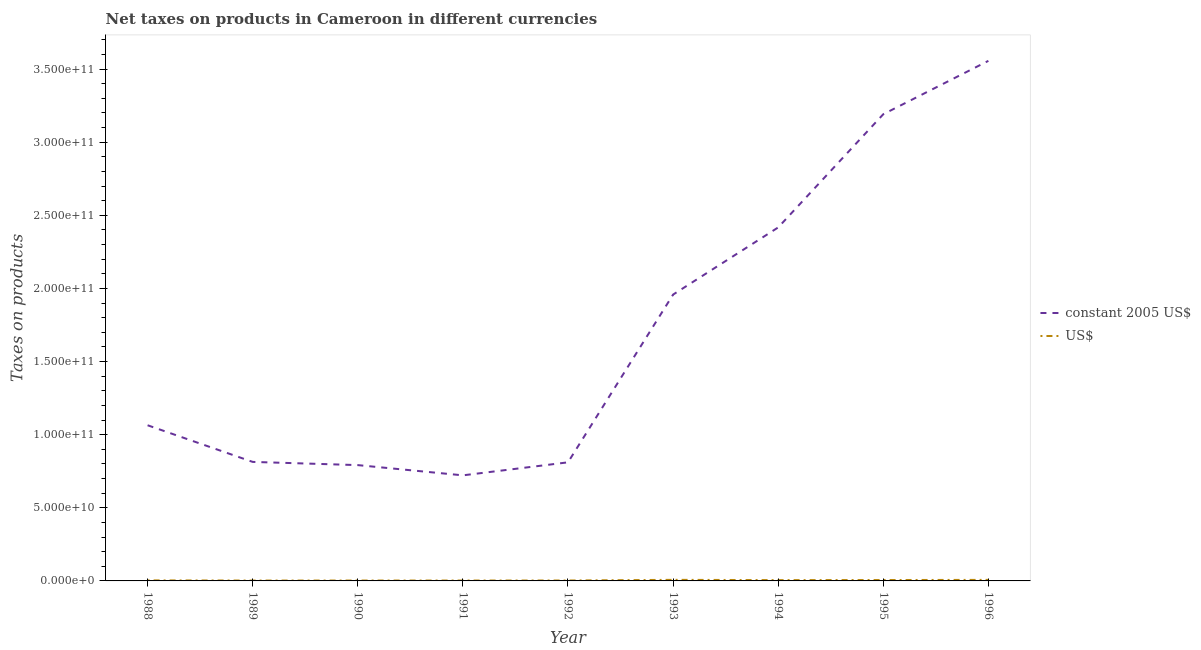Does the line corresponding to net taxes in constant 2005 us$ intersect with the line corresponding to net taxes in us$?
Your answer should be very brief. No. Is the number of lines equal to the number of legend labels?
Ensure brevity in your answer.  Yes. What is the net taxes in constant 2005 us$ in 1991?
Provide a succinct answer. 7.22e+1. Across all years, what is the maximum net taxes in us$?
Ensure brevity in your answer.  7.38e+08. Across all years, what is the minimum net taxes in us$?
Keep it short and to the point. 2.58e+08. In which year was the net taxes in constant 2005 us$ maximum?
Your response must be concise. 1996. What is the total net taxes in constant 2005 us$ in the graph?
Your response must be concise. 1.53e+12. What is the difference between the net taxes in constant 2005 us$ in 1995 and that in 1996?
Your answer should be compact. -3.65e+1. What is the difference between the net taxes in us$ in 1988 and the net taxes in constant 2005 us$ in 1990?
Offer a very short reply. -7.88e+1. What is the average net taxes in constant 2005 us$ per year?
Ensure brevity in your answer.  1.70e+11. In the year 1988, what is the difference between the net taxes in us$ and net taxes in constant 2005 us$?
Provide a short and direct response. -1.06e+11. What is the ratio of the net taxes in constant 2005 us$ in 1992 to that in 1996?
Offer a terse response. 0.23. Is the net taxes in us$ in 1990 less than that in 1991?
Your answer should be very brief. Yes. Is the difference between the net taxes in constant 2005 us$ in 1989 and 1995 greater than the difference between the net taxes in us$ in 1989 and 1995?
Provide a short and direct response. No. What is the difference between the highest and the second highest net taxes in us$?
Give a very brief answer. 2.92e+07. What is the difference between the highest and the lowest net taxes in constant 2005 us$?
Your answer should be very brief. 2.83e+11. In how many years, is the net taxes in us$ greater than the average net taxes in us$ taken over all years?
Keep it short and to the point. 4. Is the sum of the net taxes in us$ in 1988 and 1991 greater than the maximum net taxes in constant 2005 us$ across all years?
Provide a short and direct response. No. Does the net taxes in constant 2005 us$ monotonically increase over the years?
Provide a short and direct response. No. Is the net taxes in us$ strictly greater than the net taxes in constant 2005 us$ over the years?
Provide a succinct answer. No. Is the net taxes in constant 2005 us$ strictly less than the net taxes in us$ over the years?
Your answer should be very brief. No. How many lines are there?
Offer a terse response. 2. Are the values on the major ticks of Y-axis written in scientific E-notation?
Offer a very short reply. Yes. Does the graph contain any zero values?
Keep it short and to the point. No. Where does the legend appear in the graph?
Offer a terse response. Center right. How are the legend labels stacked?
Offer a terse response. Vertical. What is the title of the graph?
Make the answer very short. Net taxes on products in Cameroon in different currencies. Does "Goods and services" appear as one of the legend labels in the graph?
Your answer should be compact. No. What is the label or title of the Y-axis?
Provide a succinct answer. Taxes on products. What is the Taxes on products in constant 2005 US$ in 1988?
Offer a very short reply. 1.06e+11. What is the Taxes on products of US$ in 1988?
Provide a succinct answer. 3.65e+08. What is the Taxes on products of constant 2005 US$ in 1989?
Offer a terse response. 8.14e+1. What is the Taxes on products of US$ in 1989?
Your answer should be very brief. 2.58e+08. What is the Taxes on products of constant 2005 US$ in 1990?
Offer a very short reply. 7.92e+1. What is the Taxes on products of US$ in 1990?
Make the answer very short. 2.63e+08. What is the Taxes on products of constant 2005 US$ in 1991?
Provide a succinct answer. 7.22e+1. What is the Taxes on products of US$ in 1991?
Your response must be concise. 2.69e+08. What is the Taxes on products of constant 2005 US$ in 1992?
Offer a terse response. 8.11e+1. What is the Taxes on products in US$ in 1992?
Offer a very short reply. 2.89e+08. What is the Taxes on products in constant 2005 US$ in 1993?
Make the answer very short. 1.96e+11. What is the Taxes on products in US$ in 1993?
Offer a terse response. 7.38e+08. What is the Taxes on products of constant 2005 US$ in 1994?
Offer a very short reply. 2.42e+11. What is the Taxes on products of US$ in 1994?
Provide a short and direct response. 5.57e+08. What is the Taxes on products of constant 2005 US$ in 1995?
Provide a succinct answer. 3.19e+11. What is the Taxes on products of US$ in 1995?
Offer a terse response. 6.15e+08. What is the Taxes on products in constant 2005 US$ in 1996?
Provide a succinct answer. 3.56e+11. What is the Taxes on products in US$ in 1996?
Make the answer very short. 7.09e+08. Across all years, what is the maximum Taxes on products of constant 2005 US$?
Your response must be concise. 3.56e+11. Across all years, what is the maximum Taxes on products in US$?
Keep it short and to the point. 7.38e+08. Across all years, what is the minimum Taxes on products in constant 2005 US$?
Give a very brief answer. 7.22e+1. Across all years, what is the minimum Taxes on products of US$?
Ensure brevity in your answer.  2.58e+08. What is the total Taxes on products of constant 2005 US$ in the graph?
Keep it short and to the point. 1.53e+12. What is the total Taxes on products of US$ in the graph?
Offer a very short reply. 4.06e+09. What is the difference between the Taxes on products of constant 2005 US$ in 1988 and that in 1989?
Your answer should be very brief. 2.51e+1. What is the difference between the Taxes on products of US$ in 1988 and that in 1989?
Give a very brief answer. 1.07e+08. What is the difference between the Taxes on products in constant 2005 US$ in 1988 and that in 1990?
Offer a terse response. 2.73e+1. What is the difference between the Taxes on products of US$ in 1988 and that in 1990?
Give a very brief answer. 1.02e+08. What is the difference between the Taxes on products in constant 2005 US$ in 1988 and that in 1991?
Ensure brevity in your answer.  3.43e+1. What is the difference between the Taxes on products in US$ in 1988 and that in 1991?
Your answer should be compact. 9.62e+07. What is the difference between the Taxes on products in constant 2005 US$ in 1988 and that in 1992?
Keep it short and to the point. 2.54e+1. What is the difference between the Taxes on products of US$ in 1988 and that in 1992?
Provide a short and direct response. 7.57e+07. What is the difference between the Taxes on products in constant 2005 US$ in 1988 and that in 1993?
Give a very brief answer. -8.94e+1. What is the difference between the Taxes on products in US$ in 1988 and that in 1993?
Ensure brevity in your answer.  -3.73e+08. What is the difference between the Taxes on products of constant 2005 US$ in 1988 and that in 1994?
Ensure brevity in your answer.  -1.35e+11. What is the difference between the Taxes on products of US$ in 1988 and that in 1994?
Your answer should be very brief. -1.92e+08. What is the difference between the Taxes on products in constant 2005 US$ in 1988 and that in 1995?
Offer a very short reply. -2.13e+11. What is the difference between the Taxes on products of US$ in 1988 and that in 1995?
Offer a terse response. -2.50e+08. What is the difference between the Taxes on products in constant 2005 US$ in 1988 and that in 1996?
Provide a short and direct response. -2.49e+11. What is the difference between the Taxes on products in US$ in 1988 and that in 1996?
Provide a succinct answer. -3.44e+08. What is the difference between the Taxes on products of constant 2005 US$ in 1989 and that in 1990?
Your answer should be very brief. 2.19e+09. What is the difference between the Taxes on products of US$ in 1989 and that in 1990?
Your answer should be very brief. -5.33e+06. What is the difference between the Taxes on products of constant 2005 US$ in 1989 and that in 1991?
Keep it short and to the point. 9.19e+09. What is the difference between the Taxes on products of US$ in 1989 and that in 1991?
Keep it short and to the point. -1.07e+07. What is the difference between the Taxes on products of constant 2005 US$ in 1989 and that in 1992?
Make the answer very short. 2.93e+08. What is the difference between the Taxes on products in US$ in 1989 and that in 1992?
Give a very brief answer. -3.12e+07. What is the difference between the Taxes on products in constant 2005 US$ in 1989 and that in 1993?
Offer a terse response. -1.14e+11. What is the difference between the Taxes on products in US$ in 1989 and that in 1993?
Offer a very short reply. -4.80e+08. What is the difference between the Taxes on products of constant 2005 US$ in 1989 and that in 1994?
Make the answer very short. -1.60e+11. What is the difference between the Taxes on products of US$ in 1989 and that in 1994?
Your answer should be compact. -2.98e+08. What is the difference between the Taxes on products in constant 2005 US$ in 1989 and that in 1995?
Make the answer very short. -2.38e+11. What is the difference between the Taxes on products in US$ in 1989 and that in 1995?
Provide a succinct answer. -3.57e+08. What is the difference between the Taxes on products of constant 2005 US$ in 1989 and that in 1996?
Give a very brief answer. -2.74e+11. What is the difference between the Taxes on products of US$ in 1989 and that in 1996?
Make the answer very short. -4.51e+08. What is the difference between the Taxes on products of constant 2005 US$ in 1990 and that in 1991?
Offer a very short reply. 7.00e+09. What is the difference between the Taxes on products of US$ in 1990 and that in 1991?
Your answer should be compact. -5.35e+06. What is the difference between the Taxes on products in constant 2005 US$ in 1990 and that in 1992?
Provide a short and direct response. -1.90e+09. What is the difference between the Taxes on products in US$ in 1990 and that in 1992?
Offer a terse response. -2.58e+07. What is the difference between the Taxes on products of constant 2005 US$ in 1990 and that in 1993?
Offer a terse response. -1.17e+11. What is the difference between the Taxes on products of US$ in 1990 and that in 1993?
Keep it short and to the point. -4.74e+08. What is the difference between the Taxes on products in constant 2005 US$ in 1990 and that in 1994?
Keep it short and to the point. -1.63e+11. What is the difference between the Taxes on products of US$ in 1990 and that in 1994?
Offer a terse response. -2.93e+08. What is the difference between the Taxes on products of constant 2005 US$ in 1990 and that in 1995?
Keep it short and to the point. -2.40e+11. What is the difference between the Taxes on products of US$ in 1990 and that in 1995?
Your answer should be compact. -3.52e+08. What is the difference between the Taxes on products of constant 2005 US$ in 1990 and that in 1996?
Offer a very short reply. -2.76e+11. What is the difference between the Taxes on products in US$ in 1990 and that in 1996?
Your answer should be very brief. -4.45e+08. What is the difference between the Taxes on products in constant 2005 US$ in 1991 and that in 1992?
Your answer should be very brief. -8.90e+09. What is the difference between the Taxes on products of US$ in 1991 and that in 1992?
Make the answer very short. -2.05e+07. What is the difference between the Taxes on products of constant 2005 US$ in 1991 and that in 1993?
Your response must be concise. -1.24e+11. What is the difference between the Taxes on products in US$ in 1991 and that in 1993?
Your answer should be very brief. -4.69e+08. What is the difference between the Taxes on products of constant 2005 US$ in 1991 and that in 1994?
Your answer should be compact. -1.70e+11. What is the difference between the Taxes on products in US$ in 1991 and that in 1994?
Offer a terse response. -2.88e+08. What is the difference between the Taxes on products in constant 2005 US$ in 1991 and that in 1995?
Offer a very short reply. -2.47e+11. What is the difference between the Taxes on products in US$ in 1991 and that in 1995?
Provide a succinct answer. -3.47e+08. What is the difference between the Taxes on products of constant 2005 US$ in 1991 and that in 1996?
Provide a short and direct response. -2.83e+11. What is the difference between the Taxes on products in US$ in 1991 and that in 1996?
Your response must be concise. -4.40e+08. What is the difference between the Taxes on products in constant 2005 US$ in 1992 and that in 1993?
Offer a very short reply. -1.15e+11. What is the difference between the Taxes on products of US$ in 1992 and that in 1993?
Offer a terse response. -4.49e+08. What is the difference between the Taxes on products of constant 2005 US$ in 1992 and that in 1994?
Offer a terse response. -1.61e+11. What is the difference between the Taxes on products of US$ in 1992 and that in 1994?
Make the answer very short. -2.67e+08. What is the difference between the Taxes on products of constant 2005 US$ in 1992 and that in 1995?
Your answer should be very brief. -2.38e+11. What is the difference between the Taxes on products in US$ in 1992 and that in 1995?
Your answer should be very brief. -3.26e+08. What is the difference between the Taxes on products of constant 2005 US$ in 1992 and that in 1996?
Provide a short and direct response. -2.75e+11. What is the difference between the Taxes on products in US$ in 1992 and that in 1996?
Your answer should be very brief. -4.19e+08. What is the difference between the Taxes on products of constant 2005 US$ in 1993 and that in 1994?
Make the answer very short. -4.59e+1. What is the difference between the Taxes on products of US$ in 1993 and that in 1994?
Your answer should be very brief. 1.81e+08. What is the difference between the Taxes on products of constant 2005 US$ in 1993 and that in 1995?
Your answer should be very brief. -1.23e+11. What is the difference between the Taxes on products in US$ in 1993 and that in 1995?
Your answer should be compact. 1.22e+08. What is the difference between the Taxes on products of constant 2005 US$ in 1993 and that in 1996?
Your response must be concise. -1.60e+11. What is the difference between the Taxes on products of US$ in 1993 and that in 1996?
Your response must be concise. 2.92e+07. What is the difference between the Taxes on products in constant 2005 US$ in 1994 and that in 1995?
Offer a very short reply. -7.74e+1. What is the difference between the Taxes on products in US$ in 1994 and that in 1995?
Offer a very short reply. -5.88e+07. What is the difference between the Taxes on products of constant 2005 US$ in 1994 and that in 1996?
Make the answer very short. -1.14e+11. What is the difference between the Taxes on products in US$ in 1994 and that in 1996?
Keep it short and to the point. -1.52e+08. What is the difference between the Taxes on products in constant 2005 US$ in 1995 and that in 1996?
Ensure brevity in your answer.  -3.65e+1. What is the difference between the Taxes on products in US$ in 1995 and that in 1996?
Offer a very short reply. -9.33e+07. What is the difference between the Taxes on products of constant 2005 US$ in 1988 and the Taxes on products of US$ in 1989?
Ensure brevity in your answer.  1.06e+11. What is the difference between the Taxes on products in constant 2005 US$ in 1988 and the Taxes on products in US$ in 1990?
Provide a short and direct response. 1.06e+11. What is the difference between the Taxes on products in constant 2005 US$ in 1988 and the Taxes on products in US$ in 1991?
Offer a terse response. 1.06e+11. What is the difference between the Taxes on products of constant 2005 US$ in 1988 and the Taxes on products of US$ in 1992?
Your answer should be very brief. 1.06e+11. What is the difference between the Taxes on products in constant 2005 US$ in 1988 and the Taxes on products in US$ in 1993?
Ensure brevity in your answer.  1.06e+11. What is the difference between the Taxes on products in constant 2005 US$ in 1988 and the Taxes on products in US$ in 1994?
Your answer should be very brief. 1.06e+11. What is the difference between the Taxes on products in constant 2005 US$ in 1988 and the Taxes on products in US$ in 1995?
Your response must be concise. 1.06e+11. What is the difference between the Taxes on products in constant 2005 US$ in 1988 and the Taxes on products in US$ in 1996?
Keep it short and to the point. 1.06e+11. What is the difference between the Taxes on products of constant 2005 US$ in 1989 and the Taxes on products of US$ in 1990?
Ensure brevity in your answer.  8.11e+1. What is the difference between the Taxes on products in constant 2005 US$ in 1989 and the Taxes on products in US$ in 1991?
Your answer should be very brief. 8.11e+1. What is the difference between the Taxes on products of constant 2005 US$ in 1989 and the Taxes on products of US$ in 1992?
Your answer should be compact. 8.11e+1. What is the difference between the Taxes on products of constant 2005 US$ in 1989 and the Taxes on products of US$ in 1993?
Your answer should be compact. 8.07e+1. What is the difference between the Taxes on products of constant 2005 US$ in 1989 and the Taxes on products of US$ in 1994?
Your response must be concise. 8.08e+1. What is the difference between the Taxes on products of constant 2005 US$ in 1989 and the Taxes on products of US$ in 1995?
Make the answer very short. 8.08e+1. What is the difference between the Taxes on products of constant 2005 US$ in 1989 and the Taxes on products of US$ in 1996?
Ensure brevity in your answer.  8.07e+1. What is the difference between the Taxes on products in constant 2005 US$ in 1990 and the Taxes on products in US$ in 1991?
Give a very brief answer. 7.89e+1. What is the difference between the Taxes on products of constant 2005 US$ in 1990 and the Taxes on products of US$ in 1992?
Give a very brief answer. 7.89e+1. What is the difference between the Taxes on products of constant 2005 US$ in 1990 and the Taxes on products of US$ in 1993?
Offer a terse response. 7.85e+1. What is the difference between the Taxes on products in constant 2005 US$ in 1990 and the Taxes on products in US$ in 1994?
Make the answer very short. 7.86e+1. What is the difference between the Taxes on products of constant 2005 US$ in 1990 and the Taxes on products of US$ in 1995?
Your response must be concise. 7.86e+1. What is the difference between the Taxes on products in constant 2005 US$ in 1990 and the Taxes on products in US$ in 1996?
Your response must be concise. 7.85e+1. What is the difference between the Taxes on products in constant 2005 US$ in 1991 and the Taxes on products in US$ in 1992?
Keep it short and to the point. 7.19e+1. What is the difference between the Taxes on products of constant 2005 US$ in 1991 and the Taxes on products of US$ in 1993?
Offer a terse response. 7.15e+1. What is the difference between the Taxes on products of constant 2005 US$ in 1991 and the Taxes on products of US$ in 1994?
Keep it short and to the point. 7.16e+1. What is the difference between the Taxes on products in constant 2005 US$ in 1991 and the Taxes on products in US$ in 1995?
Give a very brief answer. 7.16e+1. What is the difference between the Taxes on products in constant 2005 US$ in 1991 and the Taxes on products in US$ in 1996?
Offer a terse response. 7.15e+1. What is the difference between the Taxes on products in constant 2005 US$ in 1992 and the Taxes on products in US$ in 1993?
Keep it short and to the point. 8.04e+1. What is the difference between the Taxes on products in constant 2005 US$ in 1992 and the Taxes on products in US$ in 1994?
Provide a succinct answer. 8.05e+1. What is the difference between the Taxes on products in constant 2005 US$ in 1992 and the Taxes on products in US$ in 1995?
Provide a short and direct response. 8.05e+1. What is the difference between the Taxes on products of constant 2005 US$ in 1992 and the Taxes on products of US$ in 1996?
Your response must be concise. 8.04e+1. What is the difference between the Taxes on products of constant 2005 US$ in 1993 and the Taxes on products of US$ in 1994?
Your answer should be very brief. 1.95e+11. What is the difference between the Taxes on products in constant 2005 US$ in 1993 and the Taxes on products in US$ in 1995?
Keep it short and to the point. 1.95e+11. What is the difference between the Taxes on products of constant 2005 US$ in 1993 and the Taxes on products of US$ in 1996?
Your response must be concise. 1.95e+11. What is the difference between the Taxes on products in constant 2005 US$ in 1994 and the Taxes on products in US$ in 1995?
Provide a short and direct response. 2.41e+11. What is the difference between the Taxes on products in constant 2005 US$ in 1994 and the Taxes on products in US$ in 1996?
Your response must be concise. 2.41e+11. What is the difference between the Taxes on products in constant 2005 US$ in 1995 and the Taxes on products in US$ in 1996?
Offer a very short reply. 3.18e+11. What is the average Taxes on products in constant 2005 US$ per year?
Your response must be concise. 1.70e+11. What is the average Taxes on products in US$ per year?
Provide a short and direct response. 4.51e+08. In the year 1988, what is the difference between the Taxes on products in constant 2005 US$ and Taxes on products in US$?
Offer a terse response. 1.06e+11. In the year 1989, what is the difference between the Taxes on products in constant 2005 US$ and Taxes on products in US$?
Provide a succinct answer. 8.11e+1. In the year 1990, what is the difference between the Taxes on products of constant 2005 US$ and Taxes on products of US$?
Make the answer very short. 7.89e+1. In the year 1991, what is the difference between the Taxes on products of constant 2005 US$ and Taxes on products of US$?
Give a very brief answer. 7.19e+1. In the year 1992, what is the difference between the Taxes on products of constant 2005 US$ and Taxes on products of US$?
Your answer should be very brief. 8.08e+1. In the year 1993, what is the difference between the Taxes on products in constant 2005 US$ and Taxes on products in US$?
Your answer should be very brief. 1.95e+11. In the year 1994, what is the difference between the Taxes on products in constant 2005 US$ and Taxes on products in US$?
Your response must be concise. 2.41e+11. In the year 1995, what is the difference between the Taxes on products of constant 2005 US$ and Taxes on products of US$?
Your answer should be very brief. 3.19e+11. In the year 1996, what is the difference between the Taxes on products of constant 2005 US$ and Taxes on products of US$?
Your answer should be compact. 3.55e+11. What is the ratio of the Taxes on products of constant 2005 US$ in 1988 to that in 1989?
Offer a terse response. 1.31. What is the ratio of the Taxes on products of US$ in 1988 to that in 1989?
Make the answer very short. 1.41. What is the ratio of the Taxes on products in constant 2005 US$ in 1988 to that in 1990?
Offer a terse response. 1.34. What is the ratio of the Taxes on products of US$ in 1988 to that in 1990?
Your answer should be compact. 1.39. What is the ratio of the Taxes on products in constant 2005 US$ in 1988 to that in 1991?
Offer a terse response. 1.47. What is the ratio of the Taxes on products in US$ in 1988 to that in 1991?
Ensure brevity in your answer.  1.36. What is the ratio of the Taxes on products in constant 2005 US$ in 1988 to that in 1992?
Your answer should be compact. 1.31. What is the ratio of the Taxes on products of US$ in 1988 to that in 1992?
Your answer should be compact. 1.26. What is the ratio of the Taxes on products in constant 2005 US$ in 1988 to that in 1993?
Provide a short and direct response. 0.54. What is the ratio of the Taxes on products in US$ in 1988 to that in 1993?
Ensure brevity in your answer.  0.49. What is the ratio of the Taxes on products in constant 2005 US$ in 1988 to that in 1994?
Offer a terse response. 0.44. What is the ratio of the Taxes on products of US$ in 1988 to that in 1994?
Provide a succinct answer. 0.66. What is the ratio of the Taxes on products of constant 2005 US$ in 1988 to that in 1995?
Your response must be concise. 0.33. What is the ratio of the Taxes on products of US$ in 1988 to that in 1995?
Provide a short and direct response. 0.59. What is the ratio of the Taxes on products of constant 2005 US$ in 1988 to that in 1996?
Offer a terse response. 0.3. What is the ratio of the Taxes on products of US$ in 1988 to that in 1996?
Offer a terse response. 0.51. What is the ratio of the Taxes on products of constant 2005 US$ in 1989 to that in 1990?
Your answer should be very brief. 1.03. What is the ratio of the Taxes on products of US$ in 1989 to that in 1990?
Your answer should be very brief. 0.98. What is the ratio of the Taxes on products in constant 2005 US$ in 1989 to that in 1991?
Your answer should be compact. 1.13. What is the ratio of the Taxes on products in US$ in 1989 to that in 1991?
Provide a short and direct response. 0.96. What is the ratio of the Taxes on products of constant 2005 US$ in 1989 to that in 1992?
Make the answer very short. 1. What is the ratio of the Taxes on products in US$ in 1989 to that in 1992?
Give a very brief answer. 0.89. What is the ratio of the Taxes on products of constant 2005 US$ in 1989 to that in 1993?
Your response must be concise. 0.42. What is the ratio of the Taxes on products of US$ in 1989 to that in 1993?
Ensure brevity in your answer.  0.35. What is the ratio of the Taxes on products of constant 2005 US$ in 1989 to that in 1994?
Your answer should be compact. 0.34. What is the ratio of the Taxes on products of US$ in 1989 to that in 1994?
Provide a short and direct response. 0.46. What is the ratio of the Taxes on products in constant 2005 US$ in 1989 to that in 1995?
Make the answer very short. 0.26. What is the ratio of the Taxes on products of US$ in 1989 to that in 1995?
Make the answer very short. 0.42. What is the ratio of the Taxes on products in constant 2005 US$ in 1989 to that in 1996?
Your response must be concise. 0.23. What is the ratio of the Taxes on products of US$ in 1989 to that in 1996?
Your response must be concise. 0.36. What is the ratio of the Taxes on products of constant 2005 US$ in 1990 to that in 1991?
Your answer should be compact. 1.1. What is the ratio of the Taxes on products of US$ in 1990 to that in 1991?
Ensure brevity in your answer.  0.98. What is the ratio of the Taxes on products in constant 2005 US$ in 1990 to that in 1992?
Give a very brief answer. 0.98. What is the ratio of the Taxes on products in US$ in 1990 to that in 1992?
Keep it short and to the point. 0.91. What is the ratio of the Taxes on products of constant 2005 US$ in 1990 to that in 1993?
Ensure brevity in your answer.  0.4. What is the ratio of the Taxes on products of US$ in 1990 to that in 1993?
Your response must be concise. 0.36. What is the ratio of the Taxes on products in constant 2005 US$ in 1990 to that in 1994?
Offer a very short reply. 0.33. What is the ratio of the Taxes on products of US$ in 1990 to that in 1994?
Provide a short and direct response. 0.47. What is the ratio of the Taxes on products in constant 2005 US$ in 1990 to that in 1995?
Your answer should be very brief. 0.25. What is the ratio of the Taxes on products of US$ in 1990 to that in 1995?
Keep it short and to the point. 0.43. What is the ratio of the Taxes on products in constant 2005 US$ in 1990 to that in 1996?
Ensure brevity in your answer.  0.22. What is the ratio of the Taxes on products in US$ in 1990 to that in 1996?
Provide a succinct answer. 0.37. What is the ratio of the Taxes on products in constant 2005 US$ in 1991 to that in 1992?
Your answer should be compact. 0.89. What is the ratio of the Taxes on products of US$ in 1991 to that in 1992?
Offer a very short reply. 0.93. What is the ratio of the Taxes on products of constant 2005 US$ in 1991 to that in 1993?
Provide a succinct answer. 0.37. What is the ratio of the Taxes on products in US$ in 1991 to that in 1993?
Give a very brief answer. 0.36. What is the ratio of the Taxes on products of constant 2005 US$ in 1991 to that in 1994?
Provide a short and direct response. 0.3. What is the ratio of the Taxes on products in US$ in 1991 to that in 1994?
Ensure brevity in your answer.  0.48. What is the ratio of the Taxes on products in constant 2005 US$ in 1991 to that in 1995?
Make the answer very short. 0.23. What is the ratio of the Taxes on products in US$ in 1991 to that in 1995?
Your answer should be very brief. 0.44. What is the ratio of the Taxes on products in constant 2005 US$ in 1991 to that in 1996?
Provide a short and direct response. 0.2. What is the ratio of the Taxes on products in US$ in 1991 to that in 1996?
Your answer should be very brief. 0.38. What is the ratio of the Taxes on products in constant 2005 US$ in 1992 to that in 1993?
Your response must be concise. 0.41. What is the ratio of the Taxes on products in US$ in 1992 to that in 1993?
Provide a succinct answer. 0.39. What is the ratio of the Taxes on products in constant 2005 US$ in 1992 to that in 1994?
Make the answer very short. 0.34. What is the ratio of the Taxes on products of US$ in 1992 to that in 1994?
Ensure brevity in your answer.  0.52. What is the ratio of the Taxes on products of constant 2005 US$ in 1992 to that in 1995?
Your answer should be compact. 0.25. What is the ratio of the Taxes on products in US$ in 1992 to that in 1995?
Offer a very short reply. 0.47. What is the ratio of the Taxes on products of constant 2005 US$ in 1992 to that in 1996?
Provide a succinct answer. 0.23. What is the ratio of the Taxes on products of US$ in 1992 to that in 1996?
Give a very brief answer. 0.41. What is the ratio of the Taxes on products of constant 2005 US$ in 1993 to that in 1994?
Your answer should be very brief. 0.81. What is the ratio of the Taxes on products of US$ in 1993 to that in 1994?
Give a very brief answer. 1.33. What is the ratio of the Taxes on products in constant 2005 US$ in 1993 to that in 1995?
Give a very brief answer. 0.61. What is the ratio of the Taxes on products in US$ in 1993 to that in 1995?
Keep it short and to the point. 1.2. What is the ratio of the Taxes on products in constant 2005 US$ in 1993 to that in 1996?
Give a very brief answer. 0.55. What is the ratio of the Taxes on products of US$ in 1993 to that in 1996?
Your response must be concise. 1.04. What is the ratio of the Taxes on products of constant 2005 US$ in 1994 to that in 1995?
Give a very brief answer. 0.76. What is the ratio of the Taxes on products in US$ in 1994 to that in 1995?
Offer a terse response. 0.9. What is the ratio of the Taxes on products in constant 2005 US$ in 1994 to that in 1996?
Offer a terse response. 0.68. What is the ratio of the Taxes on products in US$ in 1994 to that in 1996?
Give a very brief answer. 0.79. What is the ratio of the Taxes on products of constant 2005 US$ in 1995 to that in 1996?
Ensure brevity in your answer.  0.9. What is the ratio of the Taxes on products of US$ in 1995 to that in 1996?
Give a very brief answer. 0.87. What is the difference between the highest and the second highest Taxes on products in constant 2005 US$?
Provide a short and direct response. 3.65e+1. What is the difference between the highest and the second highest Taxes on products of US$?
Ensure brevity in your answer.  2.92e+07. What is the difference between the highest and the lowest Taxes on products in constant 2005 US$?
Provide a short and direct response. 2.83e+11. What is the difference between the highest and the lowest Taxes on products of US$?
Offer a very short reply. 4.80e+08. 